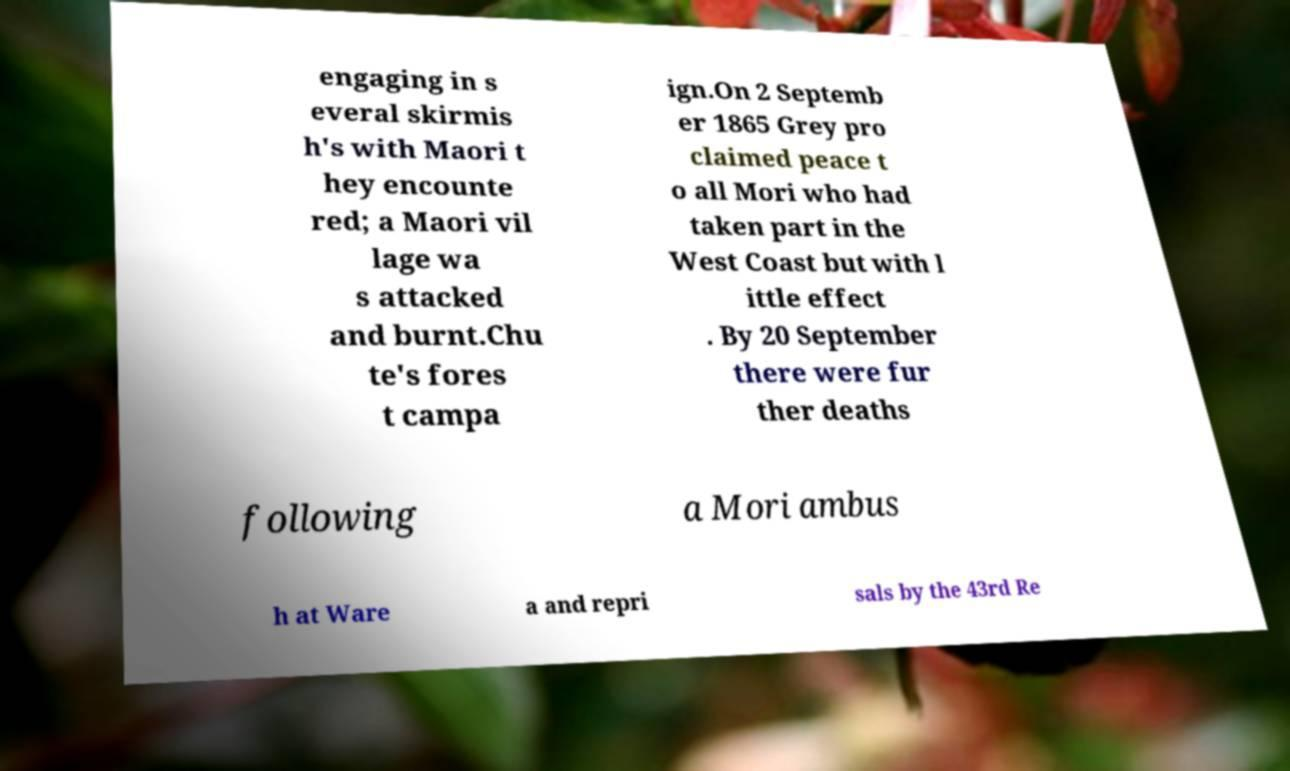Could you assist in decoding the text presented in this image and type it out clearly? engaging in s everal skirmis h's with Maori t hey encounte red; a Maori vil lage wa s attacked and burnt.Chu te's fores t campa ign.On 2 Septemb er 1865 Grey pro claimed peace t o all Mori who had taken part in the West Coast but with l ittle effect . By 20 September there were fur ther deaths following a Mori ambus h at Ware a and repri sals by the 43rd Re 